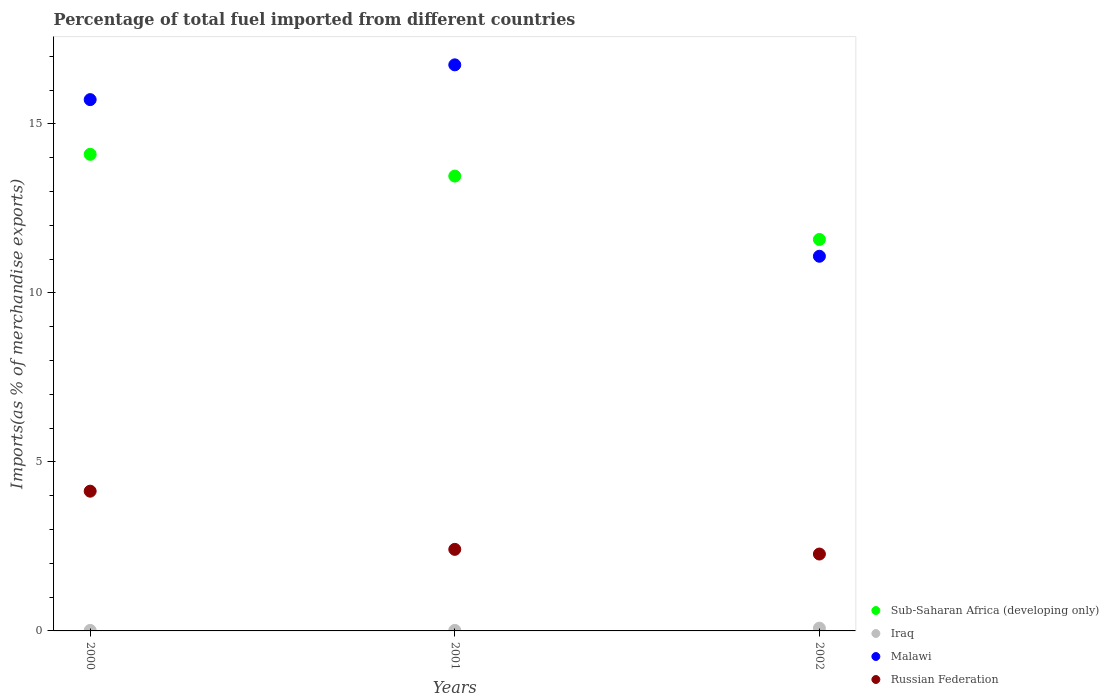Is the number of dotlines equal to the number of legend labels?
Make the answer very short. Yes. What is the percentage of imports to different countries in Sub-Saharan Africa (developing only) in 2002?
Provide a short and direct response. 11.58. Across all years, what is the maximum percentage of imports to different countries in Malawi?
Make the answer very short. 16.75. Across all years, what is the minimum percentage of imports to different countries in Russian Federation?
Make the answer very short. 2.27. In which year was the percentage of imports to different countries in Russian Federation maximum?
Your response must be concise. 2000. What is the total percentage of imports to different countries in Sub-Saharan Africa (developing only) in the graph?
Provide a short and direct response. 39.14. What is the difference between the percentage of imports to different countries in Russian Federation in 2001 and that in 2002?
Your answer should be very brief. 0.14. What is the difference between the percentage of imports to different countries in Russian Federation in 2002 and the percentage of imports to different countries in Malawi in 2000?
Provide a short and direct response. -13.44. What is the average percentage of imports to different countries in Russian Federation per year?
Provide a succinct answer. 2.94. In the year 2001, what is the difference between the percentage of imports to different countries in Malawi and percentage of imports to different countries in Iraq?
Ensure brevity in your answer.  16.73. In how many years, is the percentage of imports to different countries in Malawi greater than 7 %?
Make the answer very short. 3. What is the ratio of the percentage of imports to different countries in Russian Federation in 2000 to that in 2002?
Keep it short and to the point. 1.82. Is the difference between the percentage of imports to different countries in Malawi in 2000 and 2002 greater than the difference between the percentage of imports to different countries in Iraq in 2000 and 2002?
Your answer should be compact. Yes. What is the difference between the highest and the second highest percentage of imports to different countries in Russian Federation?
Offer a terse response. 1.72. What is the difference between the highest and the lowest percentage of imports to different countries in Russian Federation?
Make the answer very short. 1.86. In how many years, is the percentage of imports to different countries in Sub-Saharan Africa (developing only) greater than the average percentage of imports to different countries in Sub-Saharan Africa (developing only) taken over all years?
Give a very brief answer. 2. Is it the case that in every year, the sum of the percentage of imports to different countries in Sub-Saharan Africa (developing only) and percentage of imports to different countries in Malawi  is greater than the percentage of imports to different countries in Russian Federation?
Your response must be concise. Yes. Does the percentage of imports to different countries in Sub-Saharan Africa (developing only) monotonically increase over the years?
Your response must be concise. No. Is the percentage of imports to different countries in Iraq strictly less than the percentage of imports to different countries in Malawi over the years?
Provide a short and direct response. Yes. What is the difference between two consecutive major ticks on the Y-axis?
Offer a very short reply. 5. Does the graph contain any zero values?
Make the answer very short. No. Does the graph contain grids?
Your answer should be compact. No. Where does the legend appear in the graph?
Your response must be concise. Bottom right. How are the legend labels stacked?
Provide a succinct answer. Vertical. What is the title of the graph?
Your answer should be compact. Percentage of total fuel imported from different countries. What is the label or title of the X-axis?
Provide a short and direct response. Years. What is the label or title of the Y-axis?
Your answer should be very brief. Imports(as % of merchandise exports). What is the Imports(as % of merchandise exports) in Sub-Saharan Africa (developing only) in 2000?
Make the answer very short. 14.1. What is the Imports(as % of merchandise exports) in Iraq in 2000?
Your response must be concise. 0.01. What is the Imports(as % of merchandise exports) in Malawi in 2000?
Your answer should be very brief. 15.72. What is the Imports(as % of merchandise exports) of Russian Federation in 2000?
Your answer should be compact. 4.13. What is the Imports(as % of merchandise exports) of Sub-Saharan Africa (developing only) in 2001?
Your response must be concise. 13.46. What is the Imports(as % of merchandise exports) of Iraq in 2001?
Ensure brevity in your answer.  0.02. What is the Imports(as % of merchandise exports) in Malawi in 2001?
Your response must be concise. 16.75. What is the Imports(as % of merchandise exports) of Russian Federation in 2001?
Your response must be concise. 2.41. What is the Imports(as % of merchandise exports) in Sub-Saharan Africa (developing only) in 2002?
Make the answer very short. 11.58. What is the Imports(as % of merchandise exports) of Iraq in 2002?
Offer a very short reply. 0.08. What is the Imports(as % of merchandise exports) in Malawi in 2002?
Keep it short and to the point. 11.08. What is the Imports(as % of merchandise exports) of Russian Federation in 2002?
Ensure brevity in your answer.  2.27. Across all years, what is the maximum Imports(as % of merchandise exports) in Sub-Saharan Africa (developing only)?
Ensure brevity in your answer.  14.1. Across all years, what is the maximum Imports(as % of merchandise exports) in Iraq?
Give a very brief answer. 0.08. Across all years, what is the maximum Imports(as % of merchandise exports) in Malawi?
Provide a succinct answer. 16.75. Across all years, what is the maximum Imports(as % of merchandise exports) of Russian Federation?
Provide a succinct answer. 4.13. Across all years, what is the minimum Imports(as % of merchandise exports) in Sub-Saharan Africa (developing only)?
Offer a terse response. 11.58. Across all years, what is the minimum Imports(as % of merchandise exports) in Iraq?
Keep it short and to the point. 0.01. Across all years, what is the minimum Imports(as % of merchandise exports) in Malawi?
Your response must be concise. 11.08. Across all years, what is the minimum Imports(as % of merchandise exports) of Russian Federation?
Ensure brevity in your answer.  2.27. What is the total Imports(as % of merchandise exports) of Sub-Saharan Africa (developing only) in the graph?
Your response must be concise. 39.14. What is the total Imports(as % of merchandise exports) in Iraq in the graph?
Ensure brevity in your answer.  0.11. What is the total Imports(as % of merchandise exports) of Malawi in the graph?
Your response must be concise. 43.55. What is the total Imports(as % of merchandise exports) of Russian Federation in the graph?
Ensure brevity in your answer.  8.82. What is the difference between the Imports(as % of merchandise exports) in Sub-Saharan Africa (developing only) in 2000 and that in 2001?
Keep it short and to the point. 0.64. What is the difference between the Imports(as % of merchandise exports) of Iraq in 2000 and that in 2001?
Keep it short and to the point. -0. What is the difference between the Imports(as % of merchandise exports) of Malawi in 2000 and that in 2001?
Give a very brief answer. -1.03. What is the difference between the Imports(as % of merchandise exports) in Russian Federation in 2000 and that in 2001?
Ensure brevity in your answer.  1.72. What is the difference between the Imports(as % of merchandise exports) of Sub-Saharan Africa (developing only) in 2000 and that in 2002?
Keep it short and to the point. 2.52. What is the difference between the Imports(as % of merchandise exports) of Iraq in 2000 and that in 2002?
Your response must be concise. -0.07. What is the difference between the Imports(as % of merchandise exports) in Malawi in 2000 and that in 2002?
Provide a short and direct response. 4.63. What is the difference between the Imports(as % of merchandise exports) of Russian Federation in 2000 and that in 2002?
Offer a very short reply. 1.86. What is the difference between the Imports(as % of merchandise exports) of Sub-Saharan Africa (developing only) in 2001 and that in 2002?
Give a very brief answer. 1.88. What is the difference between the Imports(as % of merchandise exports) in Iraq in 2001 and that in 2002?
Your answer should be compact. -0.07. What is the difference between the Imports(as % of merchandise exports) of Malawi in 2001 and that in 2002?
Give a very brief answer. 5.66. What is the difference between the Imports(as % of merchandise exports) in Russian Federation in 2001 and that in 2002?
Your response must be concise. 0.14. What is the difference between the Imports(as % of merchandise exports) of Sub-Saharan Africa (developing only) in 2000 and the Imports(as % of merchandise exports) of Iraq in 2001?
Your response must be concise. 14.08. What is the difference between the Imports(as % of merchandise exports) in Sub-Saharan Africa (developing only) in 2000 and the Imports(as % of merchandise exports) in Malawi in 2001?
Offer a terse response. -2.65. What is the difference between the Imports(as % of merchandise exports) in Sub-Saharan Africa (developing only) in 2000 and the Imports(as % of merchandise exports) in Russian Federation in 2001?
Ensure brevity in your answer.  11.69. What is the difference between the Imports(as % of merchandise exports) of Iraq in 2000 and the Imports(as % of merchandise exports) of Malawi in 2001?
Provide a succinct answer. -16.73. What is the difference between the Imports(as % of merchandise exports) of Iraq in 2000 and the Imports(as % of merchandise exports) of Russian Federation in 2001?
Your response must be concise. -2.4. What is the difference between the Imports(as % of merchandise exports) of Malawi in 2000 and the Imports(as % of merchandise exports) of Russian Federation in 2001?
Provide a short and direct response. 13.31. What is the difference between the Imports(as % of merchandise exports) in Sub-Saharan Africa (developing only) in 2000 and the Imports(as % of merchandise exports) in Iraq in 2002?
Ensure brevity in your answer.  14.02. What is the difference between the Imports(as % of merchandise exports) of Sub-Saharan Africa (developing only) in 2000 and the Imports(as % of merchandise exports) of Malawi in 2002?
Your response must be concise. 3.02. What is the difference between the Imports(as % of merchandise exports) of Sub-Saharan Africa (developing only) in 2000 and the Imports(as % of merchandise exports) of Russian Federation in 2002?
Provide a short and direct response. 11.83. What is the difference between the Imports(as % of merchandise exports) of Iraq in 2000 and the Imports(as % of merchandise exports) of Malawi in 2002?
Your answer should be compact. -11.07. What is the difference between the Imports(as % of merchandise exports) in Iraq in 2000 and the Imports(as % of merchandise exports) in Russian Federation in 2002?
Make the answer very short. -2.26. What is the difference between the Imports(as % of merchandise exports) in Malawi in 2000 and the Imports(as % of merchandise exports) in Russian Federation in 2002?
Provide a succinct answer. 13.44. What is the difference between the Imports(as % of merchandise exports) in Sub-Saharan Africa (developing only) in 2001 and the Imports(as % of merchandise exports) in Iraq in 2002?
Ensure brevity in your answer.  13.38. What is the difference between the Imports(as % of merchandise exports) in Sub-Saharan Africa (developing only) in 2001 and the Imports(as % of merchandise exports) in Malawi in 2002?
Keep it short and to the point. 2.37. What is the difference between the Imports(as % of merchandise exports) of Sub-Saharan Africa (developing only) in 2001 and the Imports(as % of merchandise exports) of Russian Federation in 2002?
Ensure brevity in your answer.  11.18. What is the difference between the Imports(as % of merchandise exports) in Iraq in 2001 and the Imports(as % of merchandise exports) in Malawi in 2002?
Keep it short and to the point. -11.07. What is the difference between the Imports(as % of merchandise exports) in Iraq in 2001 and the Imports(as % of merchandise exports) in Russian Federation in 2002?
Provide a succinct answer. -2.26. What is the difference between the Imports(as % of merchandise exports) in Malawi in 2001 and the Imports(as % of merchandise exports) in Russian Federation in 2002?
Offer a very short reply. 14.47. What is the average Imports(as % of merchandise exports) of Sub-Saharan Africa (developing only) per year?
Offer a terse response. 13.05. What is the average Imports(as % of merchandise exports) in Iraq per year?
Keep it short and to the point. 0.04. What is the average Imports(as % of merchandise exports) in Malawi per year?
Offer a terse response. 14.52. What is the average Imports(as % of merchandise exports) of Russian Federation per year?
Provide a short and direct response. 2.94. In the year 2000, what is the difference between the Imports(as % of merchandise exports) of Sub-Saharan Africa (developing only) and Imports(as % of merchandise exports) of Iraq?
Keep it short and to the point. 14.09. In the year 2000, what is the difference between the Imports(as % of merchandise exports) of Sub-Saharan Africa (developing only) and Imports(as % of merchandise exports) of Malawi?
Ensure brevity in your answer.  -1.62. In the year 2000, what is the difference between the Imports(as % of merchandise exports) of Sub-Saharan Africa (developing only) and Imports(as % of merchandise exports) of Russian Federation?
Ensure brevity in your answer.  9.97. In the year 2000, what is the difference between the Imports(as % of merchandise exports) in Iraq and Imports(as % of merchandise exports) in Malawi?
Your response must be concise. -15.7. In the year 2000, what is the difference between the Imports(as % of merchandise exports) of Iraq and Imports(as % of merchandise exports) of Russian Federation?
Offer a terse response. -4.12. In the year 2000, what is the difference between the Imports(as % of merchandise exports) of Malawi and Imports(as % of merchandise exports) of Russian Federation?
Provide a succinct answer. 11.58. In the year 2001, what is the difference between the Imports(as % of merchandise exports) of Sub-Saharan Africa (developing only) and Imports(as % of merchandise exports) of Iraq?
Offer a very short reply. 13.44. In the year 2001, what is the difference between the Imports(as % of merchandise exports) in Sub-Saharan Africa (developing only) and Imports(as % of merchandise exports) in Malawi?
Offer a terse response. -3.29. In the year 2001, what is the difference between the Imports(as % of merchandise exports) of Sub-Saharan Africa (developing only) and Imports(as % of merchandise exports) of Russian Federation?
Provide a succinct answer. 11.04. In the year 2001, what is the difference between the Imports(as % of merchandise exports) of Iraq and Imports(as % of merchandise exports) of Malawi?
Provide a short and direct response. -16.73. In the year 2001, what is the difference between the Imports(as % of merchandise exports) of Iraq and Imports(as % of merchandise exports) of Russian Federation?
Offer a terse response. -2.4. In the year 2001, what is the difference between the Imports(as % of merchandise exports) of Malawi and Imports(as % of merchandise exports) of Russian Federation?
Your answer should be very brief. 14.33. In the year 2002, what is the difference between the Imports(as % of merchandise exports) of Sub-Saharan Africa (developing only) and Imports(as % of merchandise exports) of Malawi?
Your response must be concise. 0.5. In the year 2002, what is the difference between the Imports(as % of merchandise exports) of Sub-Saharan Africa (developing only) and Imports(as % of merchandise exports) of Russian Federation?
Provide a succinct answer. 9.31. In the year 2002, what is the difference between the Imports(as % of merchandise exports) of Iraq and Imports(as % of merchandise exports) of Malawi?
Your answer should be compact. -11. In the year 2002, what is the difference between the Imports(as % of merchandise exports) in Iraq and Imports(as % of merchandise exports) in Russian Federation?
Your answer should be very brief. -2.19. In the year 2002, what is the difference between the Imports(as % of merchandise exports) in Malawi and Imports(as % of merchandise exports) in Russian Federation?
Ensure brevity in your answer.  8.81. What is the ratio of the Imports(as % of merchandise exports) of Sub-Saharan Africa (developing only) in 2000 to that in 2001?
Keep it short and to the point. 1.05. What is the ratio of the Imports(as % of merchandise exports) of Iraq in 2000 to that in 2001?
Your answer should be very brief. 0.96. What is the ratio of the Imports(as % of merchandise exports) in Malawi in 2000 to that in 2001?
Offer a terse response. 0.94. What is the ratio of the Imports(as % of merchandise exports) of Russian Federation in 2000 to that in 2001?
Provide a short and direct response. 1.71. What is the ratio of the Imports(as % of merchandise exports) in Sub-Saharan Africa (developing only) in 2000 to that in 2002?
Offer a very short reply. 1.22. What is the ratio of the Imports(as % of merchandise exports) in Iraq in 2000 to that in 2002?
Offer a very short reply. 0.18. What is the ratio of the Imports(as % of merchandise exports) in Malawi in 2000 to that in 2002?
Your answer should be compact. 1.42. What is the ratio of the Imports(as % of merchandise exports) in Russian Federation in 2000 to that in 2002?
Provide a short and direct response. 1.82. What is the ratio of the Imports(as % of merchandise exports) of Sub-Saharan Africa (developing only) in 2001 to that in 2002?
Provide a succinct answer. 1.16. What is the ratio of the Imports(as % of merchandise exports) of Iraq in 2001 to that in 2002?
Provide a short and direct response. 0.19. What is the ratio of the Imports(as % of merchandise exports) in Malawi in 2001 to that in 2002?
Your answer should be very brief. 1.51. What is the ratio of the Imports(as % of merchandise exports) in Russian Federation in 2001 to that in 2002?
Offer a very short reply. 1.06. What is the difference between the highest and the second highest Imports(as % of merchandise exports) in Sub-Saharan Africa (developing only)?
Your response must be concise. 0.64. What is the difference between the highest and the second highest Imports(as % of merchandise exports) of Iraq?
Give a very brief answer. 0.07. What is the difference between the highest and the second highest Imports(as % of merchandise exports) of Malawi?
Provide a succinct answer. 1.03. What is the difference between the highest and the second highest Imports(as % of merchandise exports) of Russian Federation?
Ensure brevity in your answer.  1.72. What is the difference between the highest and the lowest Imports(as % of merchandise exports) of Sub-Saharan Africa (developing only)?
Your answer should be compact. 2.52. What is the difference between the highest and the lowest Imports(as % of merchandise exports) in Iraq?
Provide a succinct answer. 0.07. What is the difference between the highest and the lowest Imports(as % of merchandise exports) in Malawi?
Offer a very short reply. 5.66. What is the difference between the highest and the lowest Imports(as % of merchandise exports) in Russian Federation?
Keep it short and to the point. 1.86. 